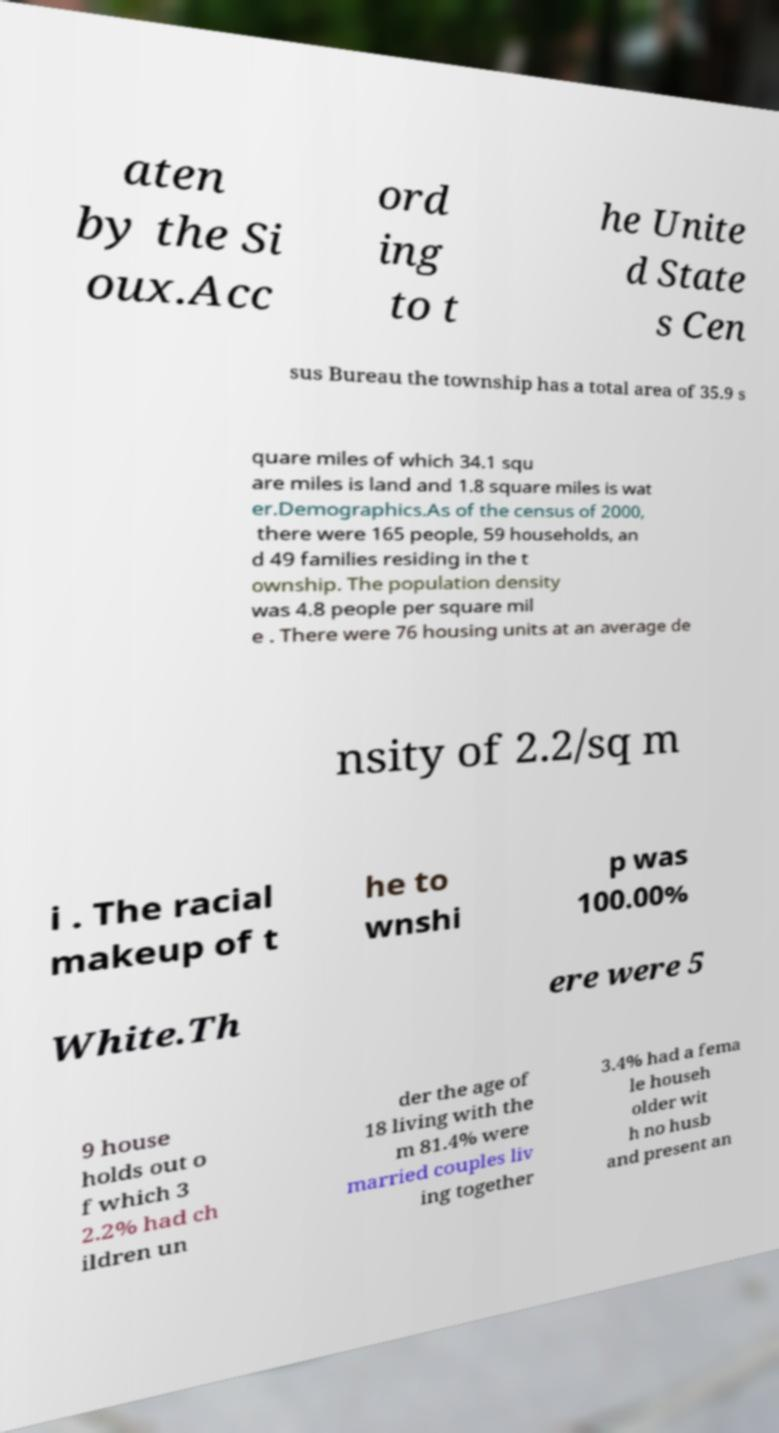For documentation purposes, I need the text within this image transcribed. Could you provide that? aten by the Si oux.Acc ord ing to t he Unite d State s Cen sus Bureau the township has a total area of 35.9 s quare miles of which 34.1 squ are miles is land and 1.8 square miles is wat er.Demographics.As of the census of 2000, there were 165 people, 59 households, an d 49 families residing in the t ownship. The population density was 4.8 people per square mil e . There were 76 housing units at an average de nsity of 2.2/sq m i . The racial makeup of t he to wnshi p was 100.00% White.Th ere were 5 9 house holds out o f which 3 2.2% had ch ildren un der the age of 18 living with the m 81.4% were married couples liv ing together 3.4% had a fema le househ older wit h no husb and present an 